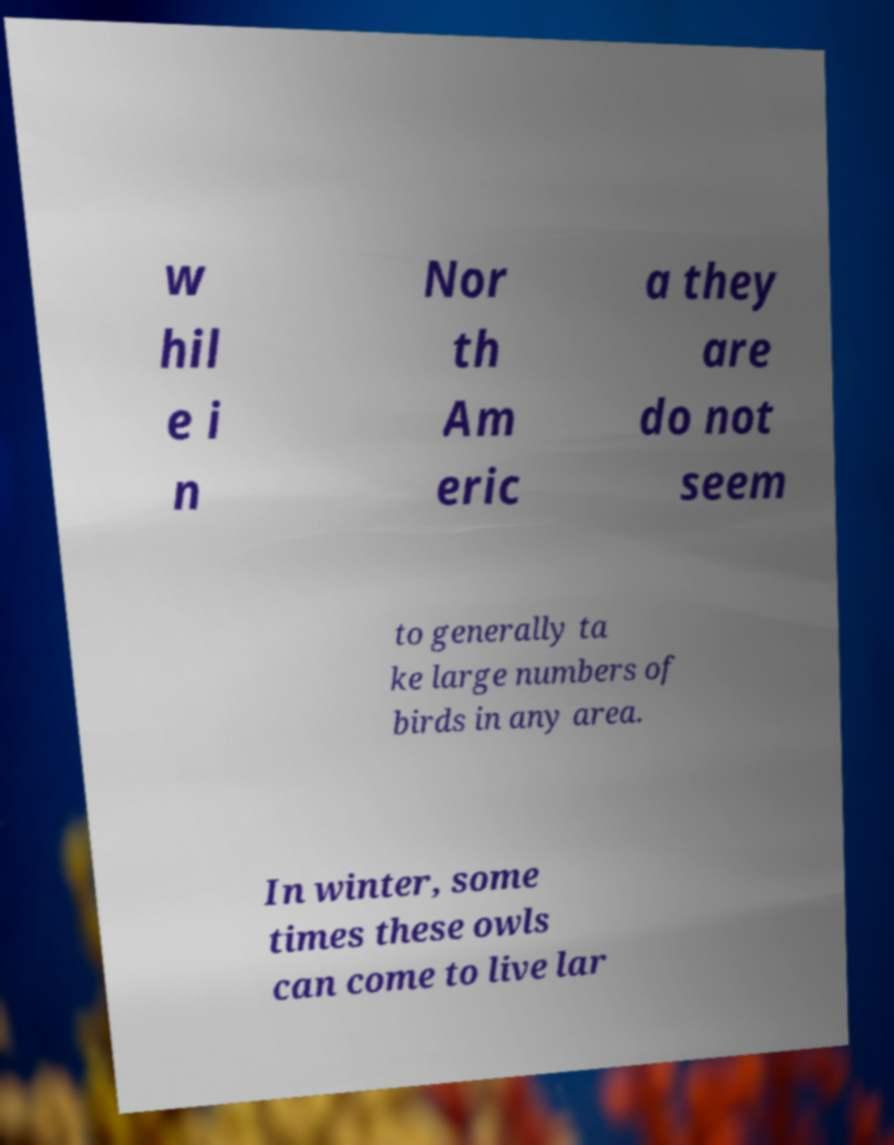I need the written content from this picture converted into text. Can you do that? w hil e i n Nor th Am eric a they are do not seem to generally ta ke large numbers of birds in any area. In winter, some times these owls can come to live lar 